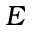<formula> <loc_0><loc_0><loc_500><loc_500>E</formula> 